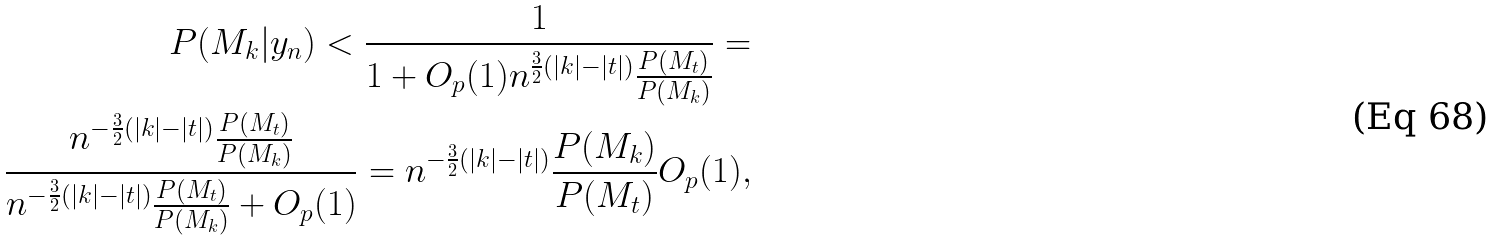Convert formula to latex. <formula><loc_0><loc_0><loc_500><loc_500>P ( M _ { k } | { y } _ { n } ) < \frac { 1 } { 1 + O _ { p } ( 1 ) n ^ { \frac { 3 } { 2 } ( | k | - | t | ) } \frac { P ( M _ { t } ) } { P ( M _ { k } ) } } = \\ \frac { n ^ { - \frac { 3 } { 2 } ( | k | - | t | ) } \frac { P ( M _ { t } ) } { P ( M _ { k } ) } } { n ^ { - \frac { 3 } { 2 } ( | k | - | t | ) } \frac { P ( M _ { t } ) } { P ( M _ { k } ) } + O _ { p } ( 1 ) } = n ^ { - \frac { 3 } { 2 } ( | k | - | t | ) } \frac { P ( M _ { k } ) } { P ( M _ { t } ) } O _ { p } ( 1 ) ,</formula> 